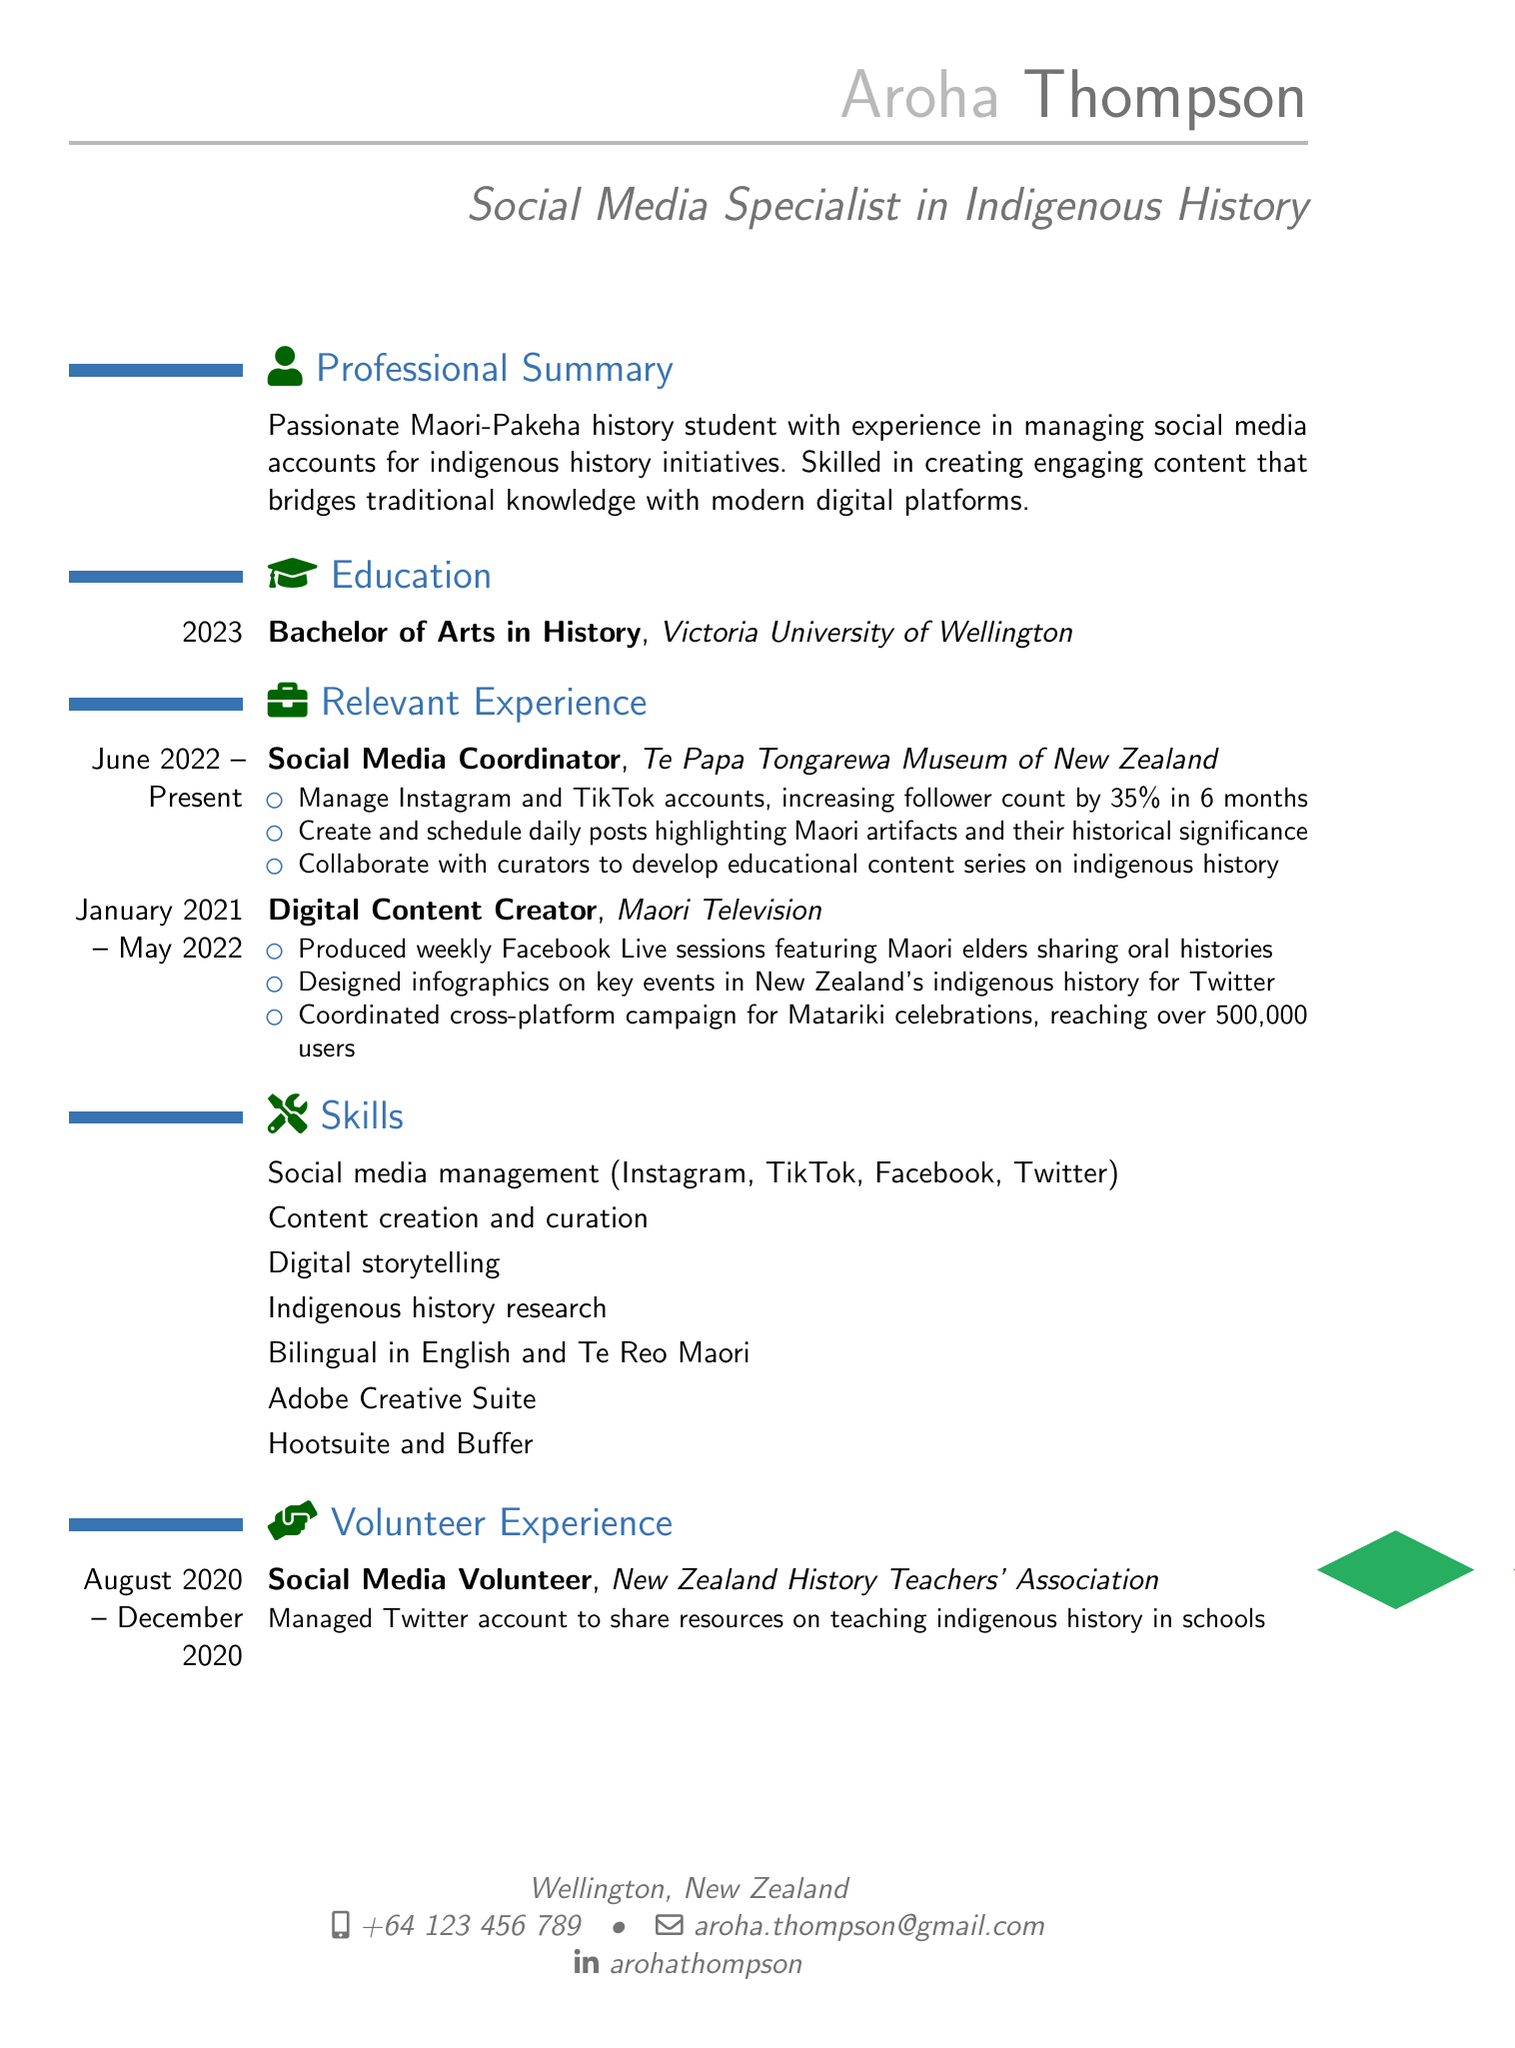What is Aroha Thompson's email address? The email address listed in the document is aroha.thompson@gmail.com.
Answer: aroha.thompson@gmail.com What degree did Aroha Thompson earn? The document states that Aroha earned a Bachelor of Arts in History.
Answer: Bachelor of Arts in History Which organization did Aroha work for as a Social Media Coordinator? According to the document, Aroha worked for Te Papa Tongarewa Museum of New Zealand as a Social Media Coordinator.
Answer: Te Papa Tongarewa Museum of New Zealand How much did Aroha increase the follower count on social media? The document mentions that Aroha increased the follower count by 35% in 6 months.
Answer: 35% What role did Aroha have at Maori Television? Aroha served as a Digital Content Creator at Maori Television.
Answer: Digital Content Creator How long did Aroha volunteer for the New Zealand History Teachers' Association? The document indicates Aroha volunteered from August 2020 to December 2020, which is 5 months.
Answer: 5 months What type of campaigns did Aroha coordinate for Matariki celebrations? The document states that Aroha coordinated a cross-platform campaign for Matariki celebrations.
Answer: Cross-platform campaign Which language besides English is Aroha bilingual in? The document notes that Aroha is bilingual in Te Reo Maori.
Answer: Te Reo Maori 